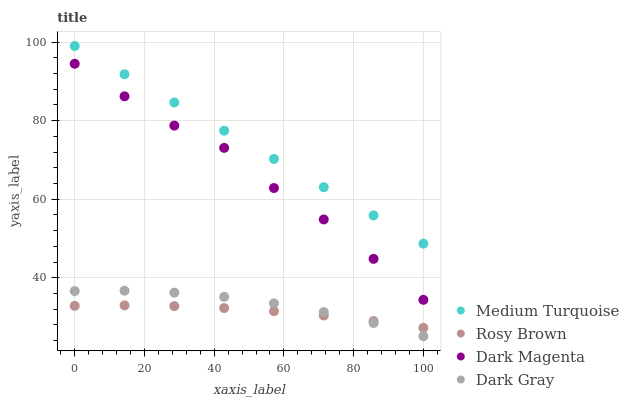Does Rosy Brown have the minimum area under the curve?
Answer yes or no. Yes. Does Medium Turquoise have the maximum area under the curve?
Answer yes or no. Yes. Does Dark Magenta have the minimum area under the curve?
Answer yes or no. No. Does Dark Magenta have the maximum area under the curve?
Answer yes or no. No. Is Medium Turquoise the smoothest?
Answer yes or no. Yes. Is Dark Magenta the roughest?
Answer yes or no. Yes. Is Rosy Brown the smoothest?
Answer yes or no. No. Is Rosy Brown the roughest?
Answer yes or no. No. Does Dark Gray have the lowest value?
Answer yes or no. Yes. Does Rosy Brown have the lowest value?
Answer yes or no. No. Does Medium Turquoise have the highest value?
Answer yes or no. Yes. Does Dark Magenta have the highest value?
Answer yes or no. No. Is Dark Magenta less than Medium Turquoise?
Answer yes or no. Yes. Is Dark Magenta greater than Dark Gray?
Answer yes or no. Yes. Does Rosy Brown intersect Dark Gray?
Answer yes or no. Yes. Is Rosy Brown less than Dark Gray?
Answer yes or no. No. Is Rosy Brown greater than Dark Gray?
Answer yes or no. No. Does Dark Magenta intersect Medium Turquoise?
Answer yes or no. No. 